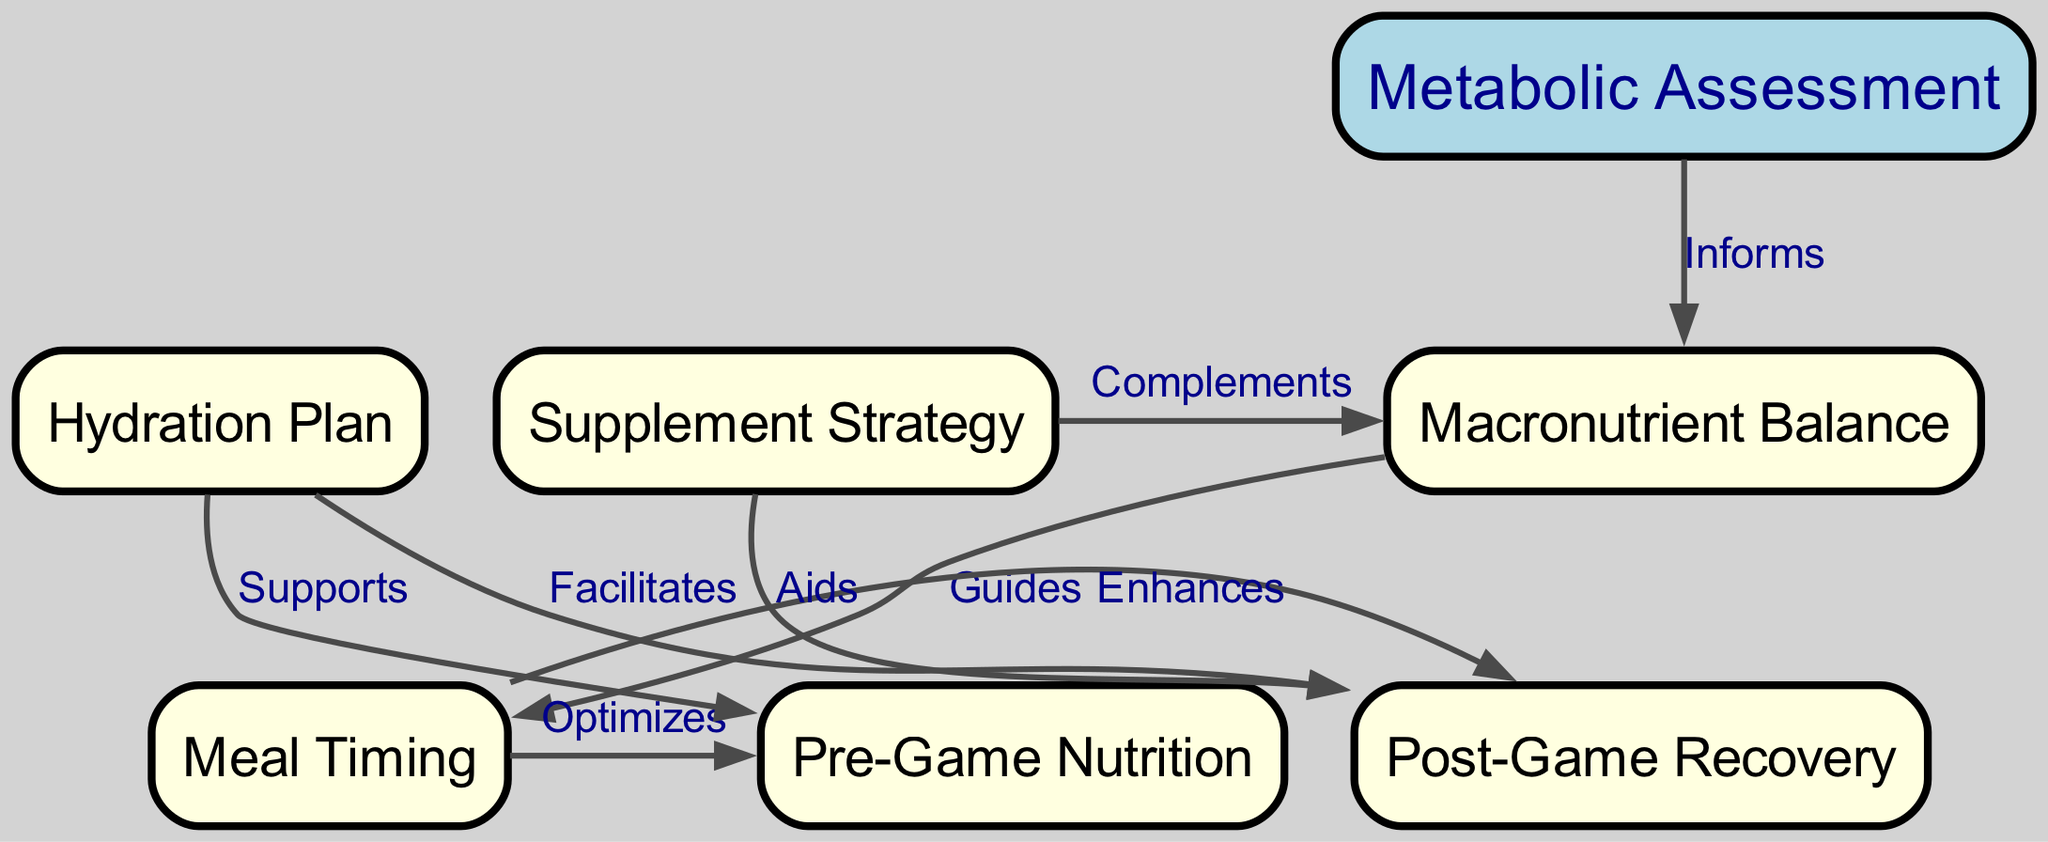What is the primary focus of the first node? The first node is labeled "Metabolic Assessment," which indicates that this is the main focus of the diagram, as it's at the starting point of the strategy.
Answer: Metabolic Assessment How many edges are there connecting the nodes? By counting the connections displayed in the edges list, there are a total of 8 edges that link the nodes together.
Answer: 8 Which node is linked to both "Pre-Game Nutrition" and "Post-Game Recovery"? The third node, labeled "Meal Timing," connects with both "Pre-Game Nutrition" and "Post-Game Recovery," as indicated by the outgoing arrows in the diagram.
Answer: Meal Timing What type of relationship exists between "Hydration Plan" and "Pre-Game Nutrition"? The edge labeled "Supports" indicates that the Hydration Plan directly supports Pre-Game Nutrition as shown by the directed relationship between these two nodes.
Answer: Supports How does "Supplement Strategy" connect to "Macronutrient Balance"? The edge labeled "Complements" from "Supplement Strategy" to "Macronutrient Balance" shows that it is a complementary relationship, enhancing the macronutrient balance.
Answer: Complements What is the role of "Post-Game Recovery" in relation to "Meal Timing"? "Meal Timing" is linked to "Post-Game Recovery" with an "Enhances" labeled edge, indicating that optimal meal timing enhances the recovery process after the game.
Answer: Enhances Which node provides guidance to "Meal Timing"? The node labeled "Macronutrient Balance" informs the "Meal Timing," which shows that the balance of macronutrients plays a crucial role in determining the timing of meals.
Answer: Macronutrient Balance Which node facilitates recovery post-game? The "Hydration Plan" facilitates recovery post-game by directly linking to "Post-Game Recovery," demonstrating the importance of hydration in the recovery process.
Answer: Hydration Plan 